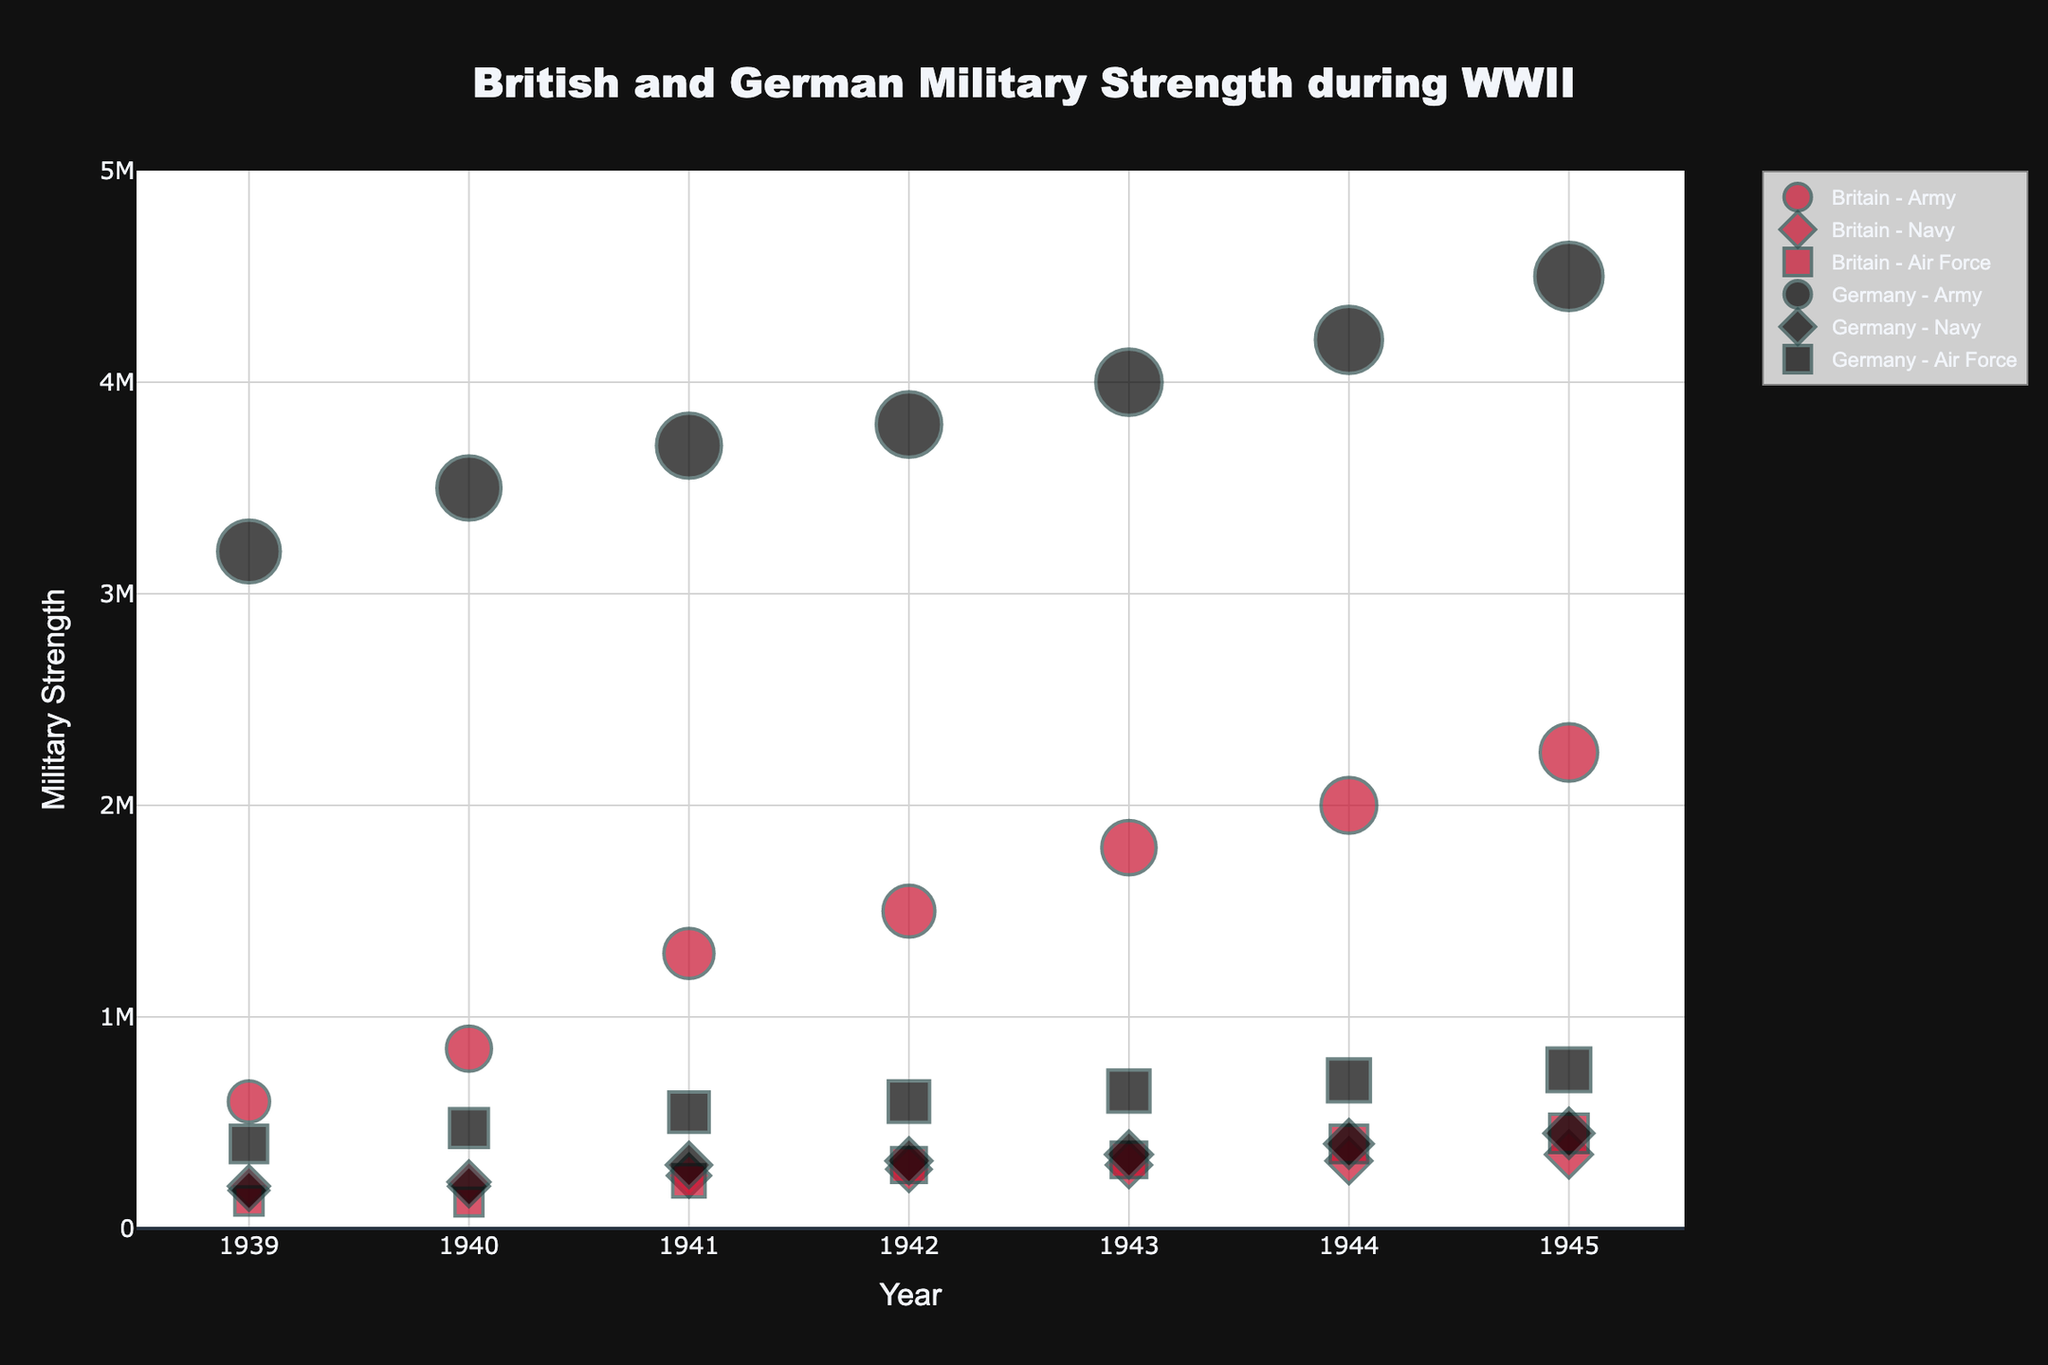What is the title of the chart? The title is present at the top center of the chart in a larger font size. It is "British and German Military Strength during WWII".
Answer: British and German Military Strength during WWII Which country had a stronger army in 1943? To compare, look at the sizes of the bubbles for 1943 under 'Army' for both Britain and Germany. Germany's bubble is larger indicating a higher strength.
Answer: Germany How did the strength of the British Air Force change from 1939 to 1945? Track the British Air Force bubbles from 1939 to 1945, the bubble sizes correspond to: 130,000 in 1939, 125,000 in 1940, 225,000 in 1941, 300,000 in 1942, 325,000 in 1943, 400,000 in 1944, and 450,000 in 1945. The strength consistently increased.
Answer: Increased By how much did the German Navy's strength increase from 1939 to 1945? Check the bubble sizes for the German Navy in 1939 and 1945. In 1939, it was 180,000, and in 1945, it was 450,000. The increase is 450,000 - 180,000 = 270,000.
Answer: 270,000 In which year did Britain have the highest number of army personnel? Look for the largest bubble for the British Army across all years. The highest bubble is in 1945, with 2,250,000 personnel.
Answer: 1945 Which branch had the largest increase in strength for Britain between 1944 and 1945? Compare the British branches' strength for 1944 and 1945: Army (2,000,000 to 2,250,000, increase of 250,000), Navy (320,000 to 350,000, increase of 30,000), Air Force (400,000 to 450,000, increase of 50,000). The Army had the largest increase.
Answer: Army How did the strength of the German Air Force in 1945 compare to its strength in 1941? Check the bubbles for the German Air Force in 1941 and 1945. In 1941 it was 550,000, and in 1945 it was 750,000. So, the 1945 strength was higher by 200,000.
Answer: Higher by 200,000 Was the strength of the British Army in 1940 greater than the combined strength of the British Navy and Air Force in 1939? Calculate the total strength of the British Navy and Air Force in 1939: 200,000 (Navy) + 130,000 (Air Force) = 330,000. Compare with the British Army in 1940 which is 850,000. 850,000 is greater than 330,000.
Answer: Yes How consistent was the increase in Germany's army strength from 1939 to 1945? Observe the trend in the German Army's bubble sizes from 1939 (3,200,000) to 1945 (4,500,000): the increases are 3,500,000 in 1940, 3,700,000 in 1941, 3,800,000 in 1942, 4,000,000 in 1943, 4,200,000 in 1944, and 4,500,000 in 1945. The increases are relatively consistent.
Answer: Relatively consistent 